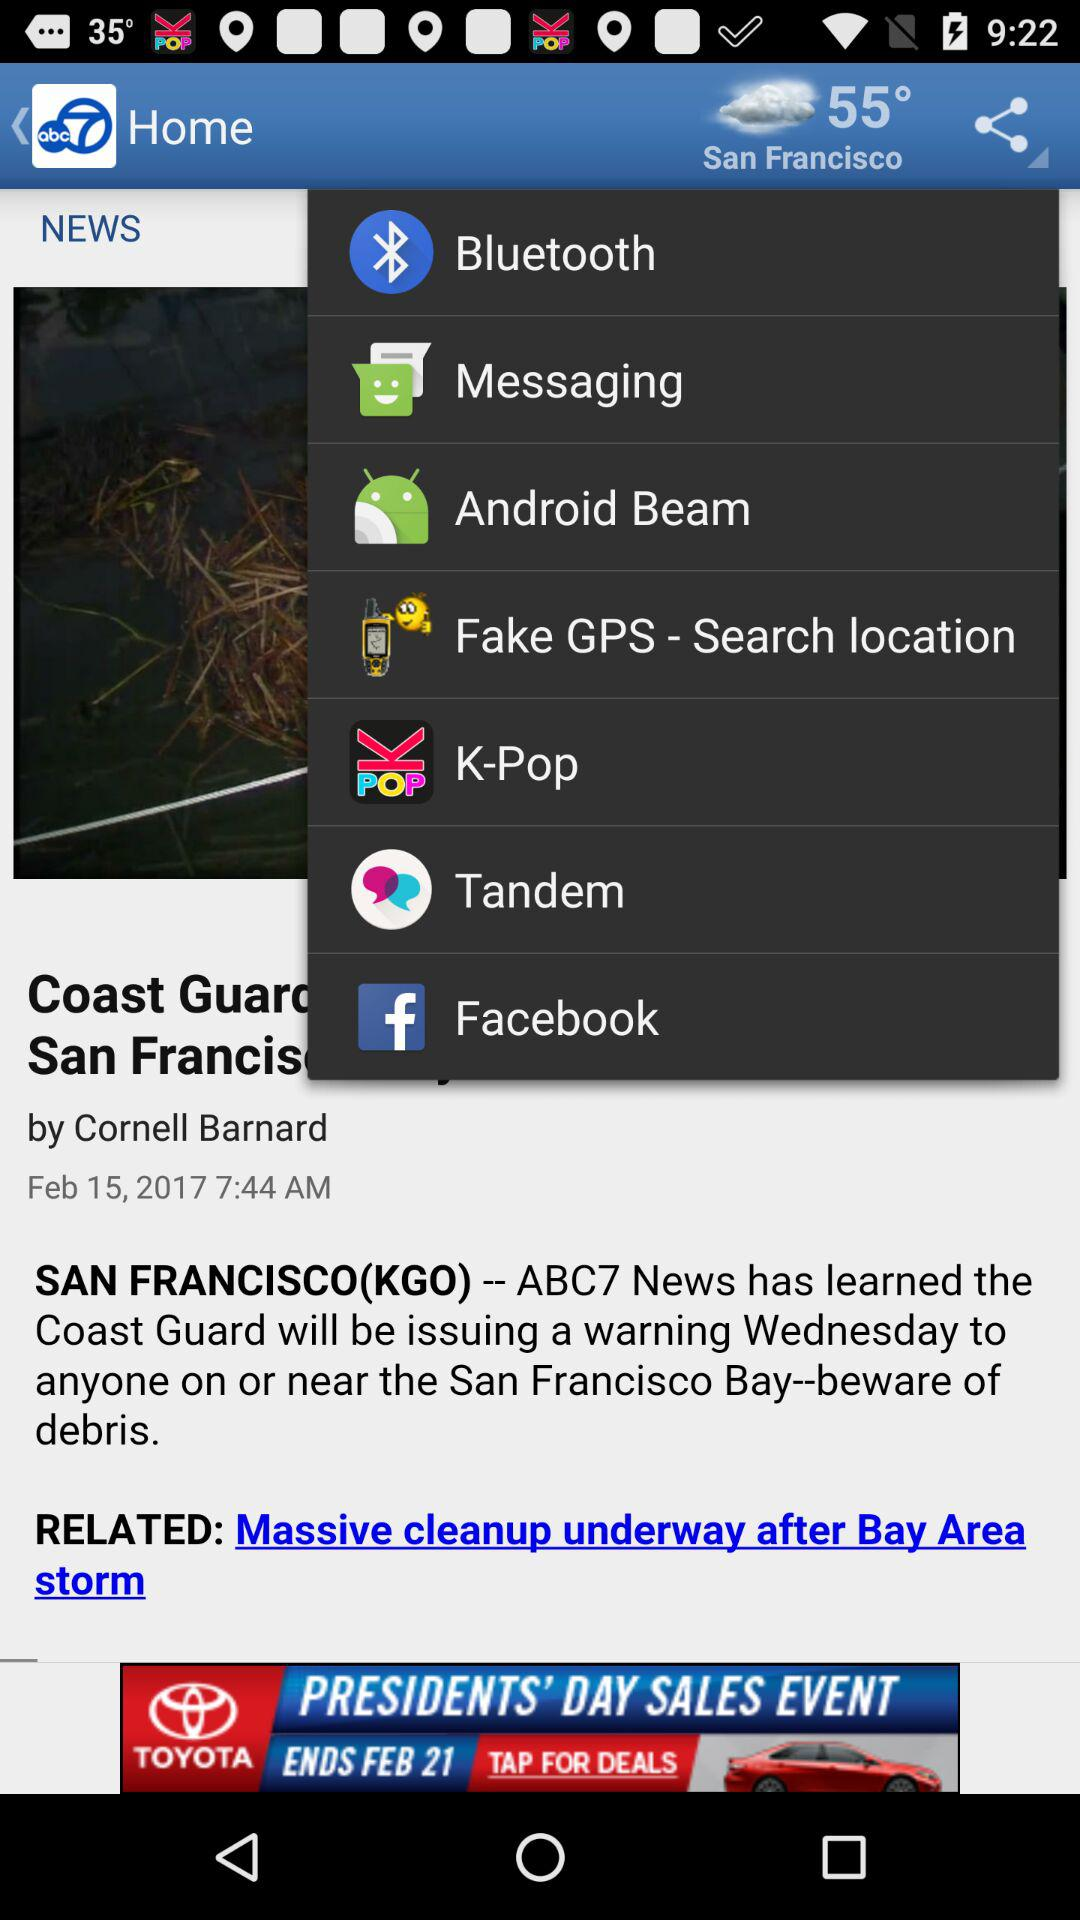What is the temperature in San Francisco? The temperature is 55°. 